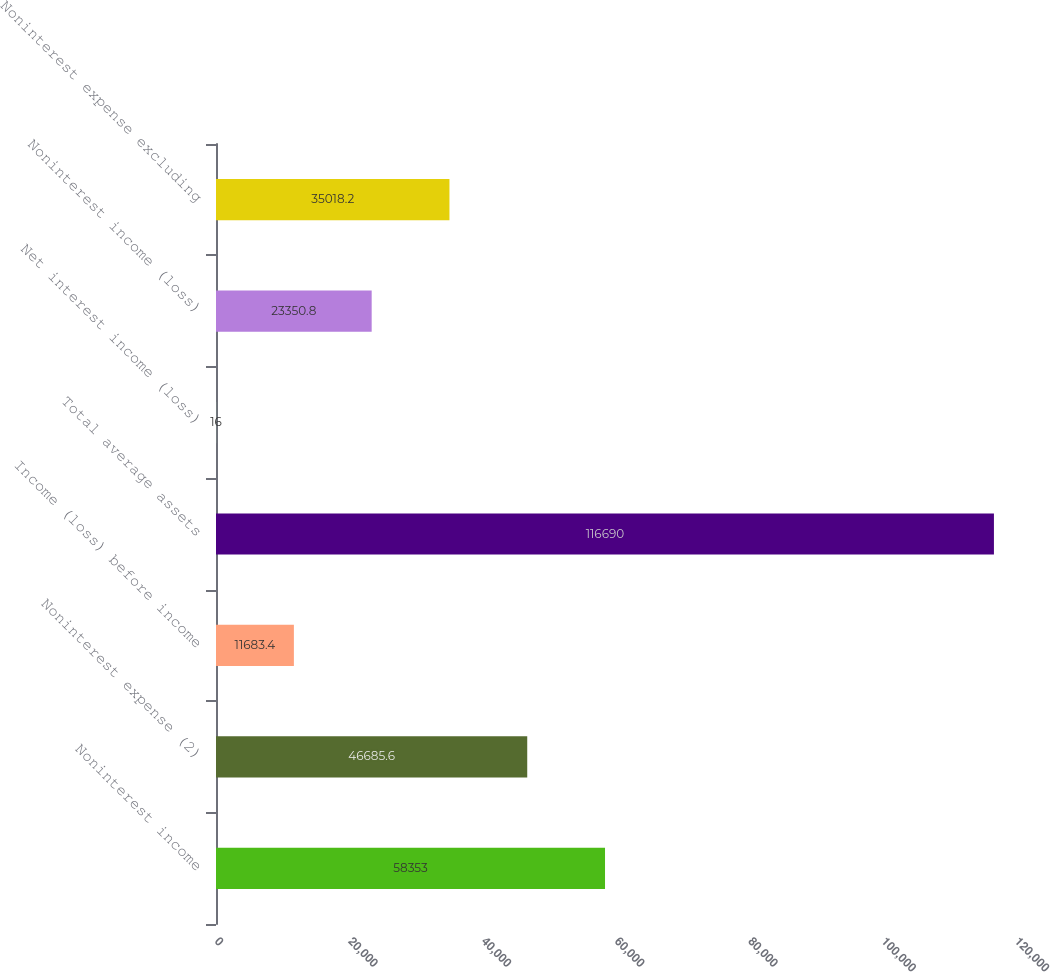<chart> <loc_0><loc_0><loc_500><loc_500><bar_chart><fcel>Noninterest income<fcel>Noninterest expense (2)<fcel>Income (loss) before income<fcel>Total average assets<fcel>Net interest income (loss)<fcel>Noninterest income (loss)<fcel>Noninterest expense excluding<nl><fcel>58353<fcel>46685.6<fcel>11683.4<fcel>116690<fcel>16<fcel>23350.8<fcel>35018.2<nl></chart> 